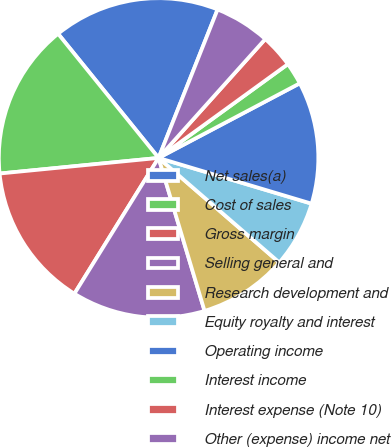Convert chart to OTSL. <chart><loc_0><loc_0><loc_500><loc_500><pie_chart><fcel>Net sales(a)<fcel>Cost of sales<fcel>Gross margin<fcel>Selling general and<fcel>Research development and<fcel>Equity royalty and interest<fcel>Operating income<fcel>Interest income<fcel>Interest expense (Note 10)<fcel>Other (expense) income net<nl><fcel>16.85%<fcel>15.73%<fcel>14.61%<fcel>13.48%<fcel>8.99%<fcel>6.74%<fcel>12.36%<fcel>2.25%<fcel>3.37%<fcel>5.62%<nl></chart> 